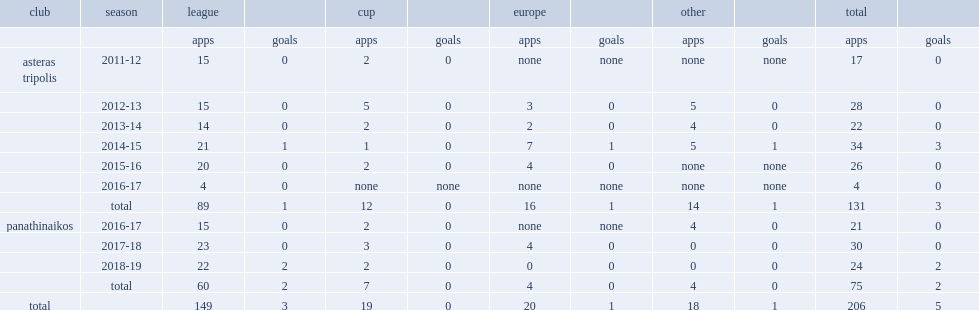What was the number of appearances made by dimitris kourbelis for tripoli totally? 131.0. 